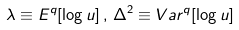Convert formula to latex. <formula><loc_0><loc_0><loc_500><loc_500>\lambda \equiv E ^ { q } [ \log u ] \, , \, \Delta ^ { 2 } \equiv V a r ^ { q } [ \log u ]</formula> 